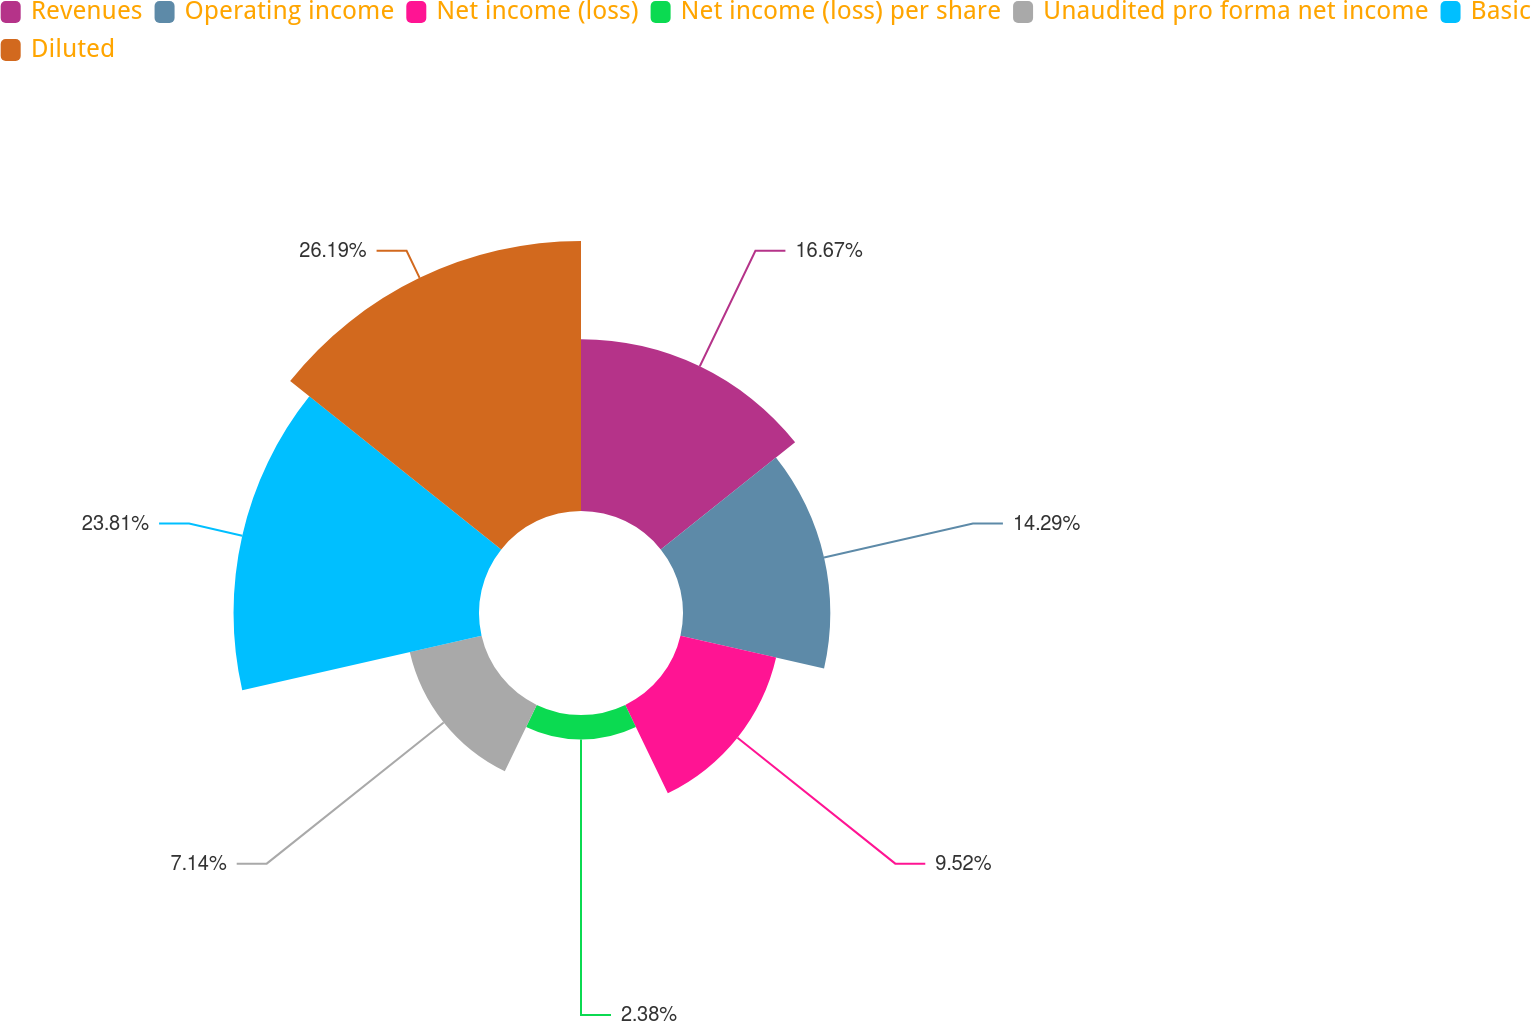<chart> <loc_0><loc_0><loc_500><loc_500><pie_chart><fcel>Revenues<fcel>Operating income<fcel>Net income (loss)<fcel>Net income (loss) per share<fcel>Unaudited pro forma net income<fcel>Basic<fcel>Diluted<nl><fcel>16.67%<fcel>14.29%<fcel>9.52%<fcel>2.38%<fcel>7.14%<fcel>23.81%<fcel>26.19%<nl></chart> 